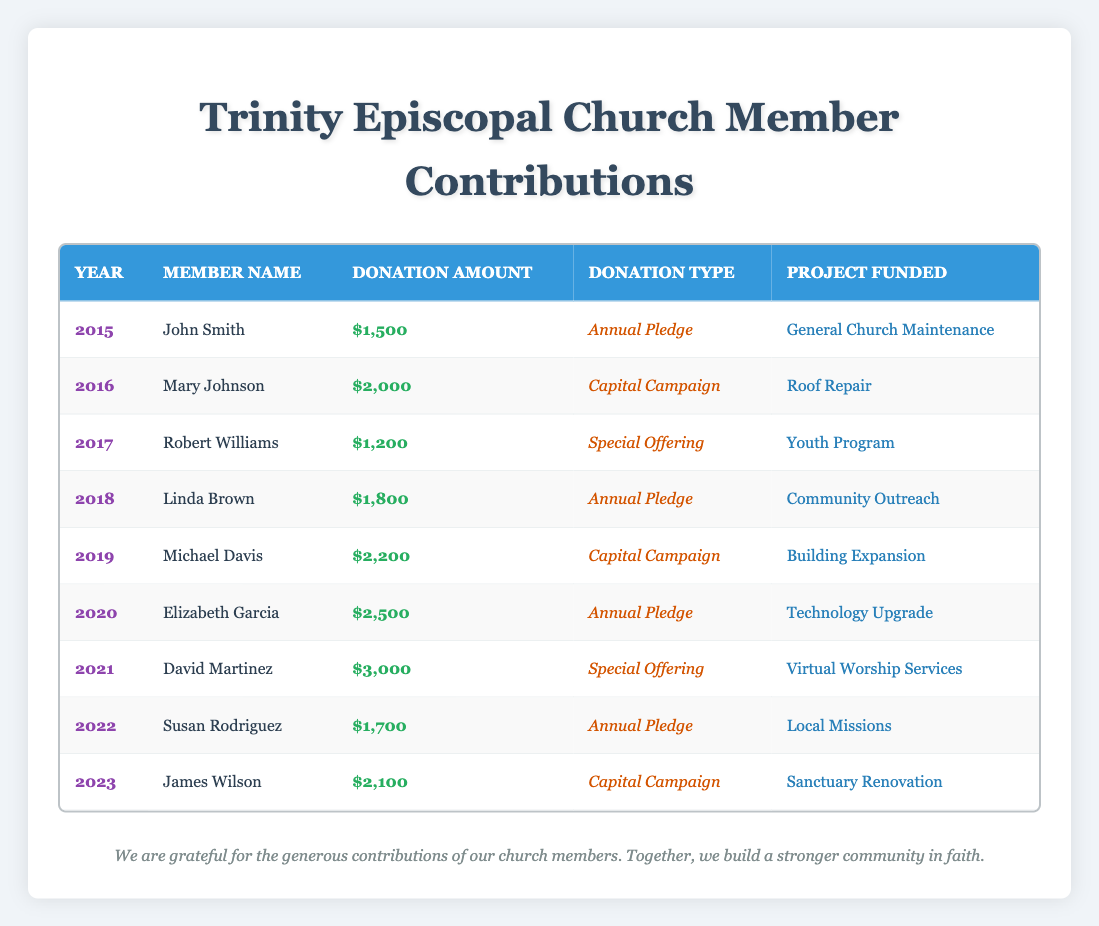What is the total donation amount from 2015 to 2023? To find the total, we sum the donation amounts for each year: 1500 + 2000 + 1200 + 1800 + 2200 + 2500 + 3000 + 1700 + 2100 = 20,500.
Answer: 20500 Which member contributed the highest amount? We compare the donation amounts for all members listed. David Martinez contributed the highest amount of 3000 in 2021.
Answer: David Martinez How many members made contributions in 2020 and 2021? There were two contributions: one from Elizabeth Garcia in 2020 and one from David Martinez in 2021.
Answer: 2 Was every year represented by a unique member, or did some members contribute in different years? Each year was represented by a different member, with no members repeating contributions in multiple years.
Answer: Yes What is the average donation amount per year from 2015 to 2023? There are 9 donations over 9 years. The total donation is 20500. Therefore, the average is 20500 / 9 ≈ 2277.78.
Answer: 2277.78 Which type of donation had the highest total amount contributed? The total for each type: Annual Pledge (1500 + 1800 + 2500 + 1700 = 7500), Capital Campaign (2000 + 2200 + 2100 = 6300), Special Offering (1200 + 3000 = 4200). Annual Pledge has the highest total, which is 7500.
Answer: Annual Pledge In which year was the second highest contribution made, and by whom? The highest contribution is 3000 (David Martinez in 2021). The second highest is 2500 (Elizabeth Garcia in 2020).
Answer: 2020, Elizabeth Garcia How many years did contributions go toward a Capital Campaign? Contributions for Capital Campaign were made in 2016, 2019, and 2023. Thus, contributions were made in 3 different years for this purpose.
Answer: 3 Did any contributions support community outreach projects? Yes, the contribution by Linda Brown in 2018 supported Community Outreach with a donation of 1800.
Answer: Yes 